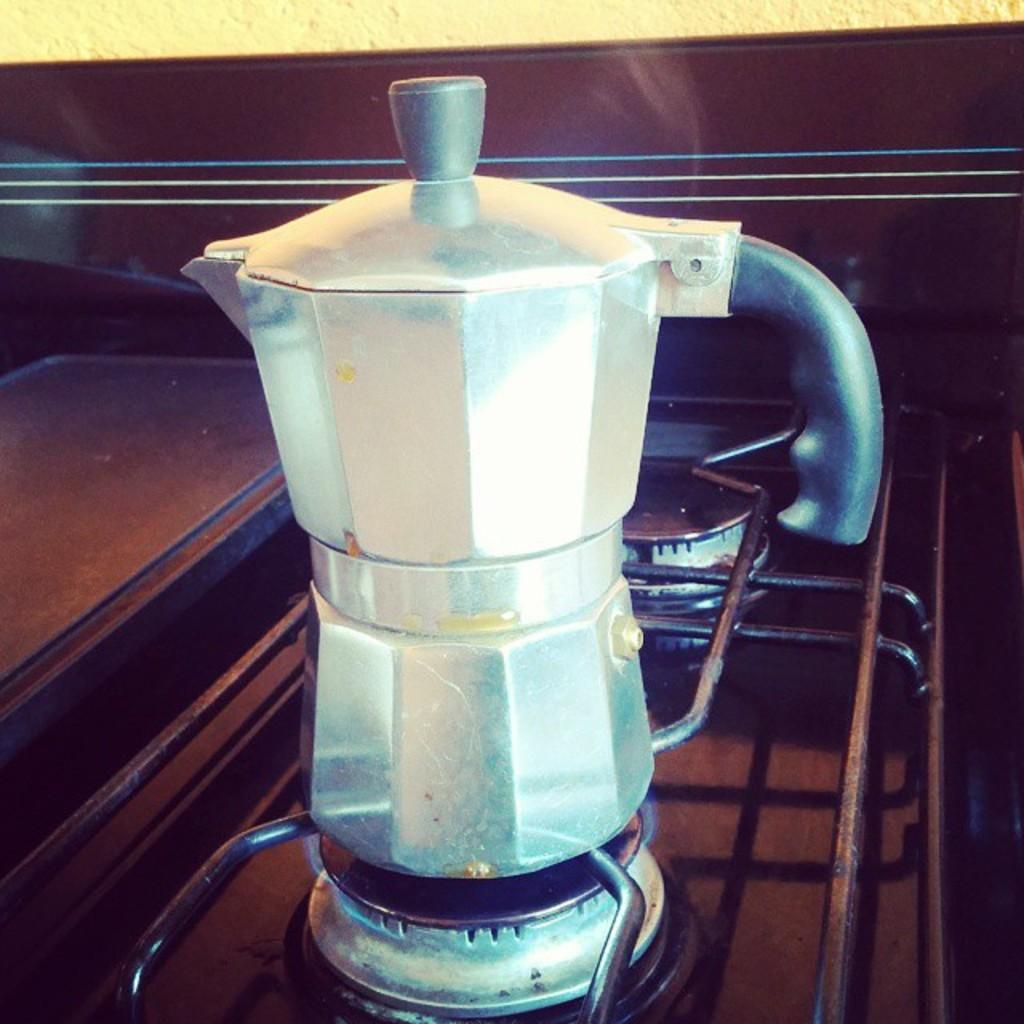What object is the main focus of the image? There is a jar in the image. Where is the jar located? The jar is placed on a wooden table. What type of hat can be seen on the seashore in the image? There is no hat or seashore present in the image; it only features a jar on a wooden table. 